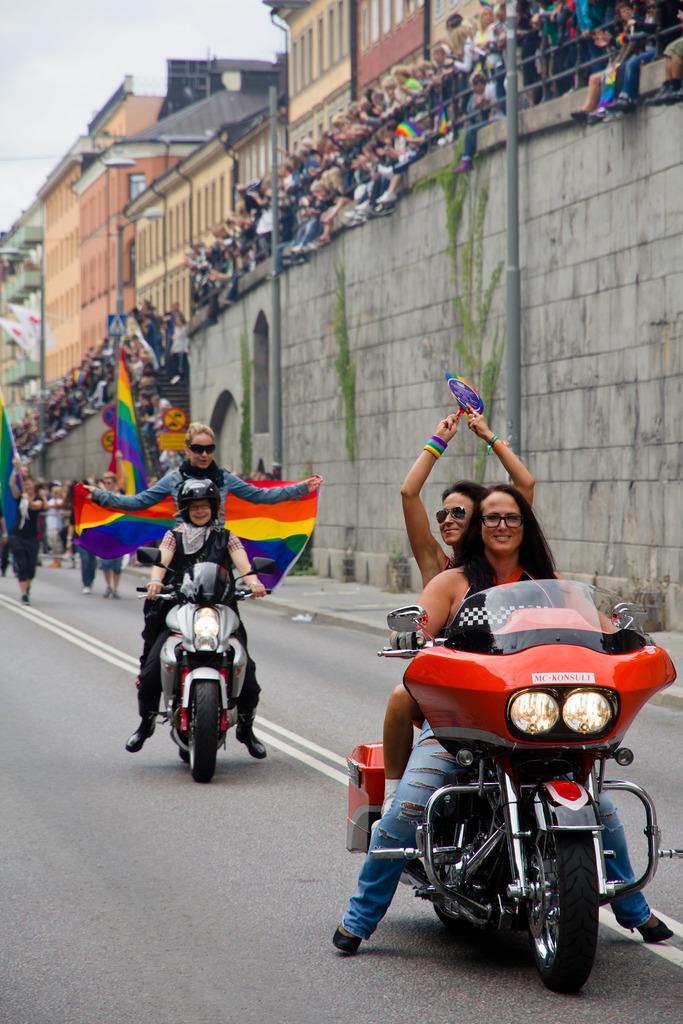How would you summarize this image in a sentence or two? In this image i can see few persons riding bike on road at the right side i can see few other persons standing and a building at a top there is sky. 